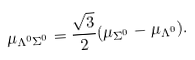Convert formula to latex. <formula><loc_0><loc_0><loc_500><loc_500>\mu _ { \Lambda ^ { 0 } \Sigma ^ { 0 } } = \frac { \sqrt { 3 } } { 2 } ( \mu _ { \Sigma ^ { 0 } } - \mu _ { \Lambda ^ { 0 } } ) .</formula> 